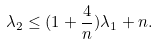Convert formula to latex. <formula><loc_0><loc_0><loc_500><loc_500>\lambda _ { 2 } \leq ( 1 + \frac { 4 } { n } ) \lambda _ { 1 } + n .</formula> 